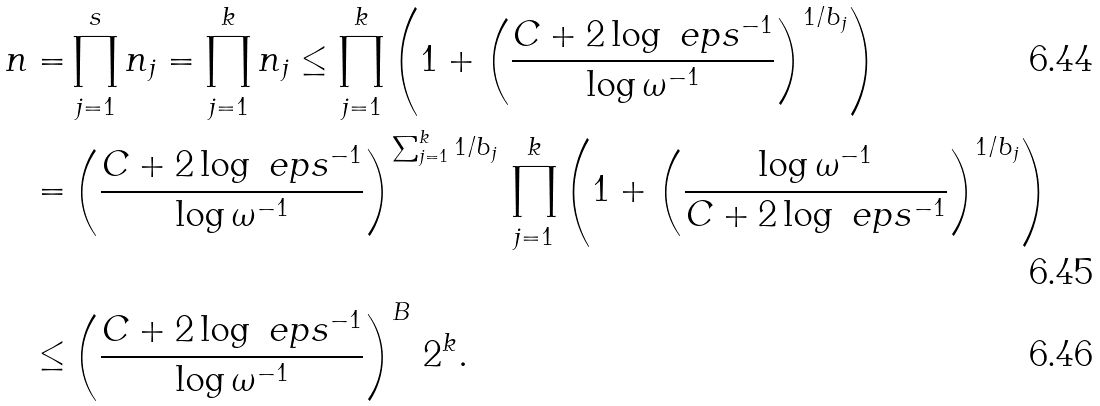<formula> <loc_0><loc_0><loc_500><loc_500>n = & \prod _ { j = 1 } ^ { s } n _ { j } = \prod _ { j = 1 } ^ { k } n _ { j } \leq \prod _ { j = 1 } ^ { k } \left ( 1 + \left ( \frac { C + 2 \log \ e p s ^ { - 1 } } { \log \omega ^ { - 1 } } \right ) ^ { 1 / b _ { j } } \right ) \\ = & \left ( \frac { C + 2 \log \ e p s ^ { - 1 } } { \log \omega ^ { - 1 } } \right ) ^ { \sum _ { j = 1 } ^ { k } 1 / b _ { j } } \, \prod _ { j = 1 } ^ { k } \left ( 1 + \left ( \frac { \log \omega ^ { - 1 } } { C + 2 \log \ e p s ^ { - 1 } } \right ) ^ { 1 / b _ { j } } \right ) \\ \leq & \left ( \frac { C + 2 \log \ e p s ^ { - 1 } } { \log \omega ^ { - 1 } } \right ) ^ { B } \, 2 ^ { k } .</formula> 